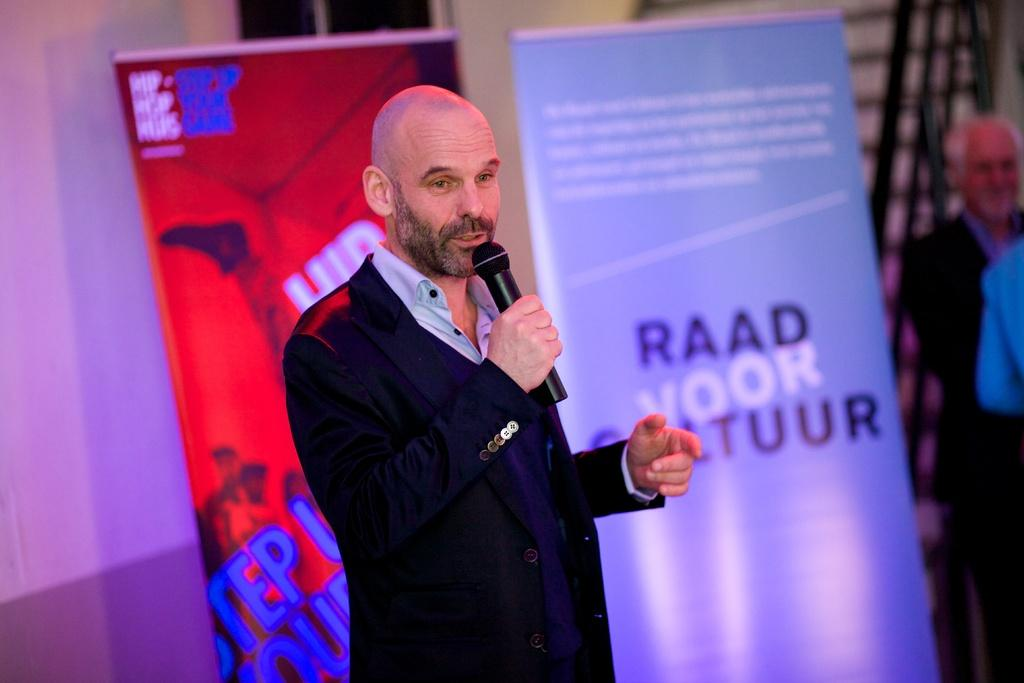How many people are in the image? There are people in the image, but the exact number is not specified. What is one person doing in the image? One person is holding a mic and talking. What can be seen on the banners in the image? There are two banners with text in the image. What is visible in the background element in the image? There is a wall visible in the image. What type of chicken is being served on the plate in the image? There is no plate or chicken present in the image. What color is the grape that the person is holding in the image? There is no grape or person holding a grape in the image. 